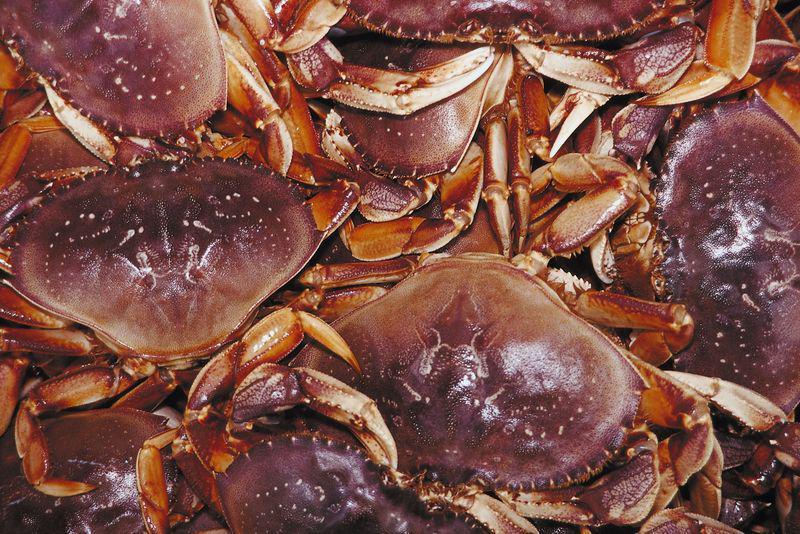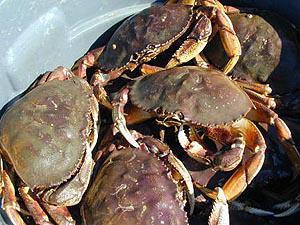The first image is the image on the left, the second image is the image on the right. Assess this claim about the two images: "There are cables wrapping around the outside of the crate the crabs are in.". Correct or not? Answer yes or no. No. The first image is the image on the left, the second image is the image on the right. For the images displayed, is the sentence "The crabs in the image on the right are sitting in a brightly colored container." factually correct? Answer yes or no. No. 